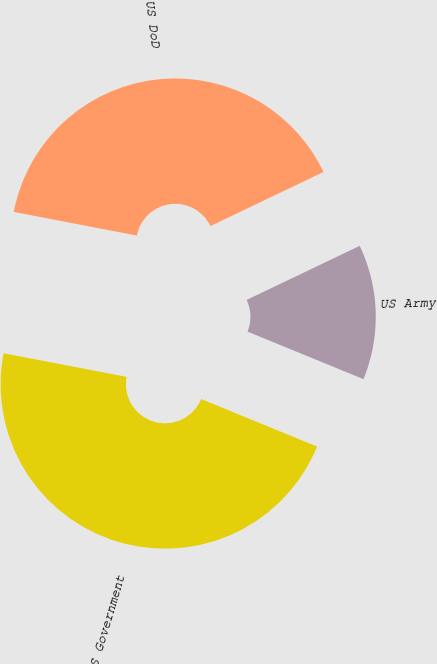<chart> <loc_0><loc_0><loc_500><loc_500><pie_chart><fcel>US Government<fcel>US DoD<fcel>US Army<nl><fcel>46.82%<fcel>39.88%<fcel>13.29%<nl></chart> 